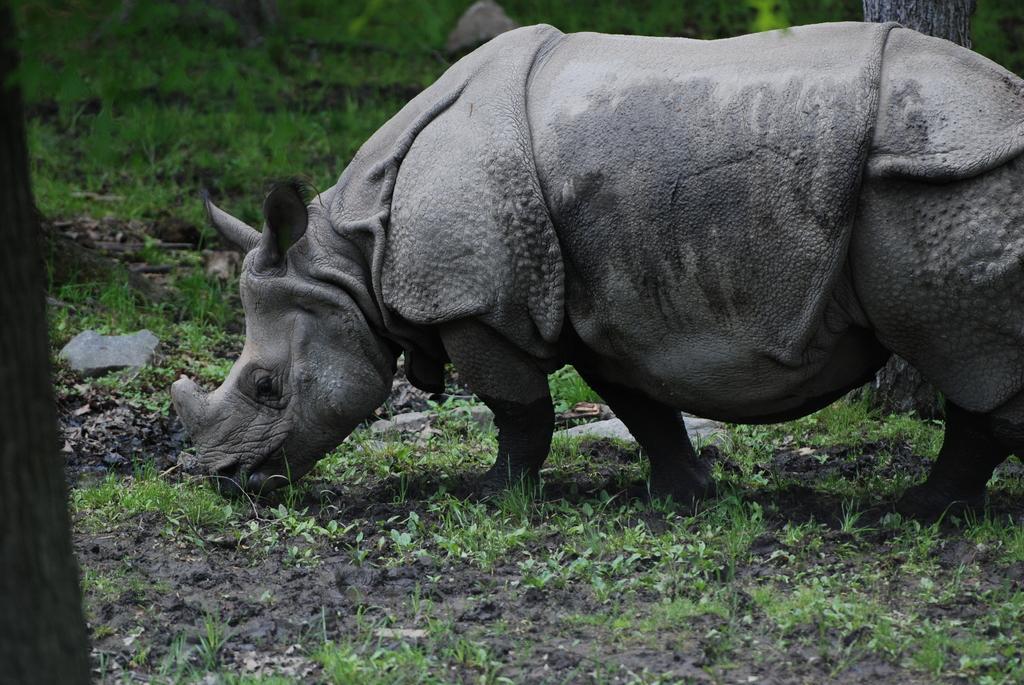Can you describe this image briefly? In this picture there is a rhinoceros, grazing. In the foreground there are plants, grass and mud. The background is blurred. In the background there are grass, stone and tree. 